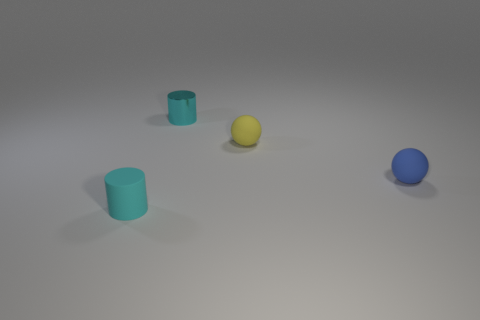Add 2 small things. How many objects exist? 6 Subtract all tiny purple metal cylinders. Subtract all small rubber cylinders. How many objects are left? 3 Add 3 tiny blue things. How many tiny blue things are left? 4 Add 3 large yellow metallic blocks. How many large yellow metallic blocks exist? 3 Subtract 0 cyan spheres. How many objects are left? 4 